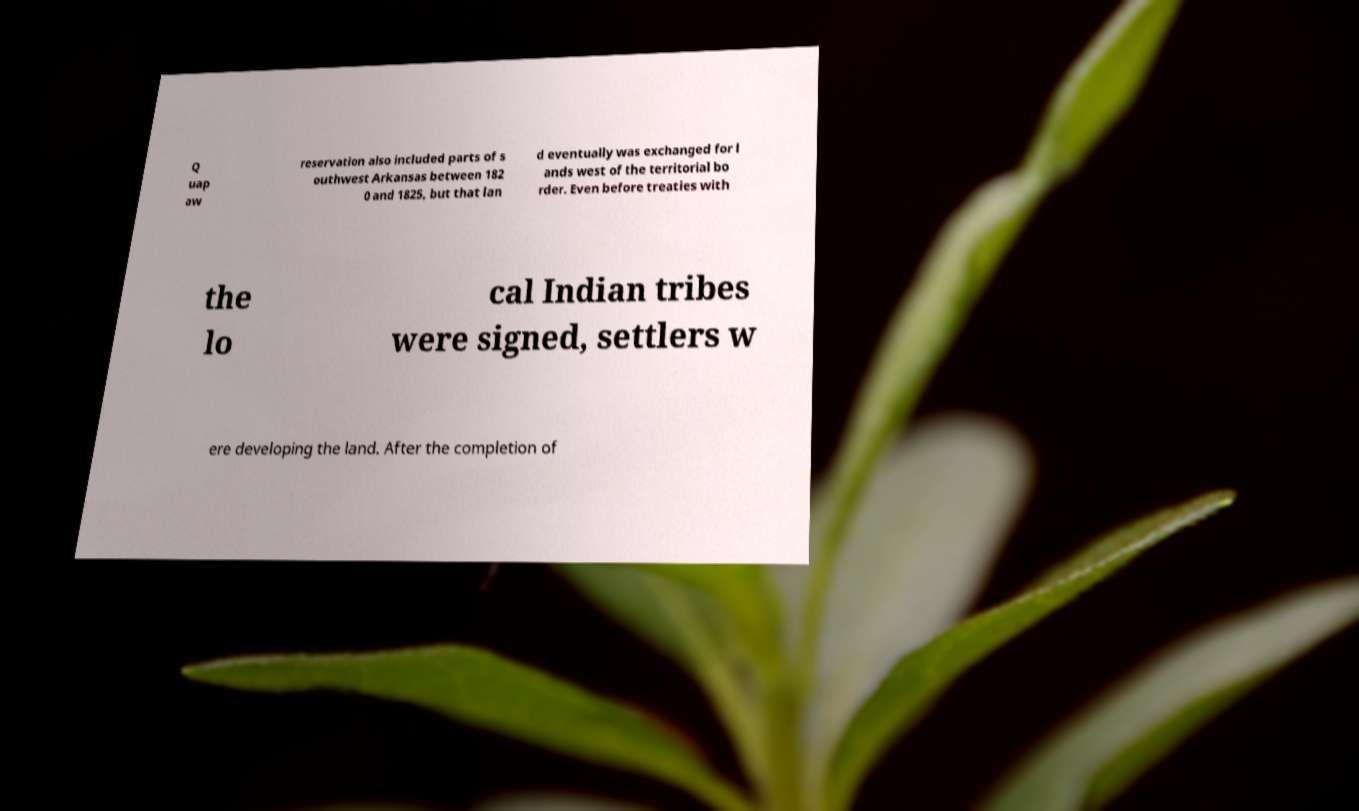Please identify and transcribe the text found in this image. Q uap aw reservation also included parts of s outhwest Arkansas between 182 0 and 1825, but that lan d eventually was exchanged for l ands west of the territorial bo rder. Even before treaties with the lo cal Indian tribes were signed, settlers w ere developing the land. After the completion of 